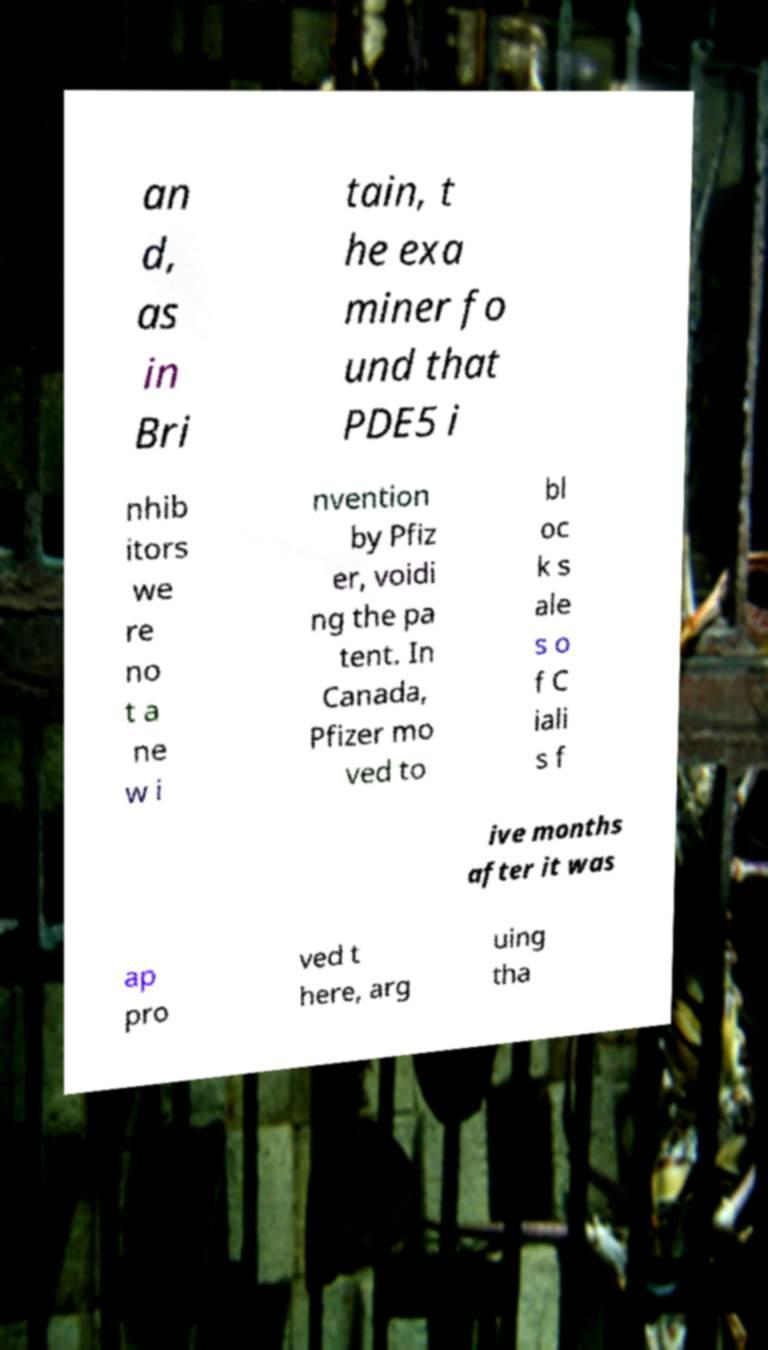Could you extract and type out the text from this image? an d, as in Bri tain, t he exa miner fo und that PDE5 i nhib itors we re no t a ne w i nvention by Pfiz er, voidi ng the pa tent. In Canada, Pfizer mo ved to bl oc k s ale s o f C iali s f ive months after it was ap pro ved t here, arg uing tha 